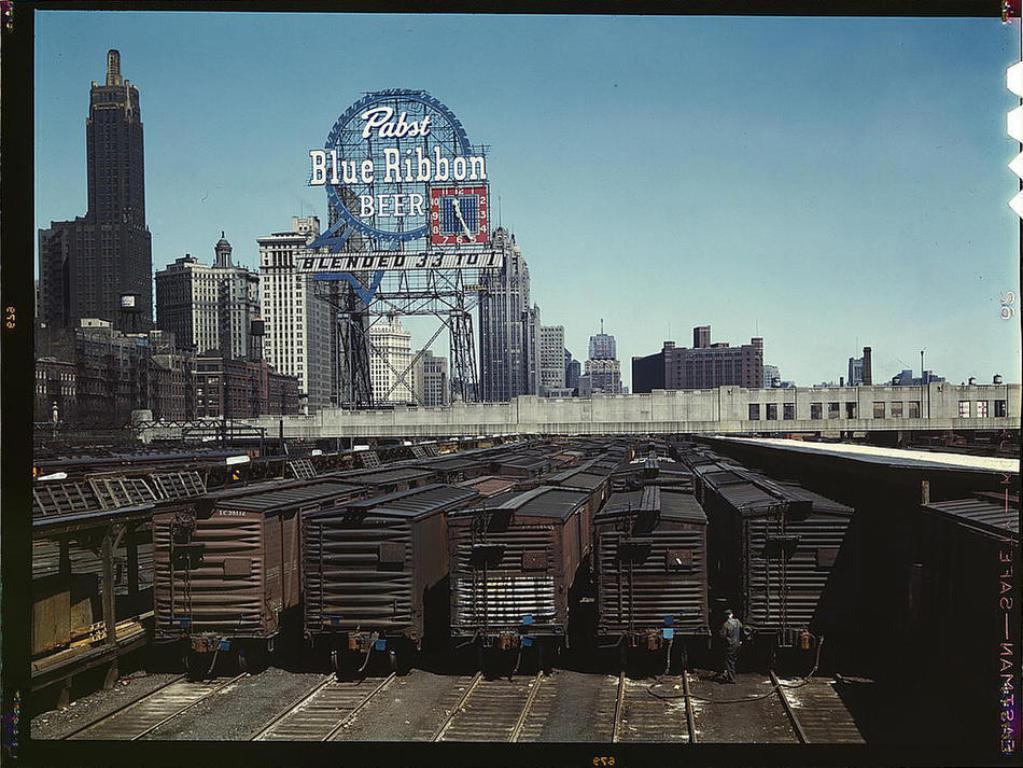Could you give a brief overview of what you see in this image? In this picture there are few trains on the tracks and there are buildings in the background. 